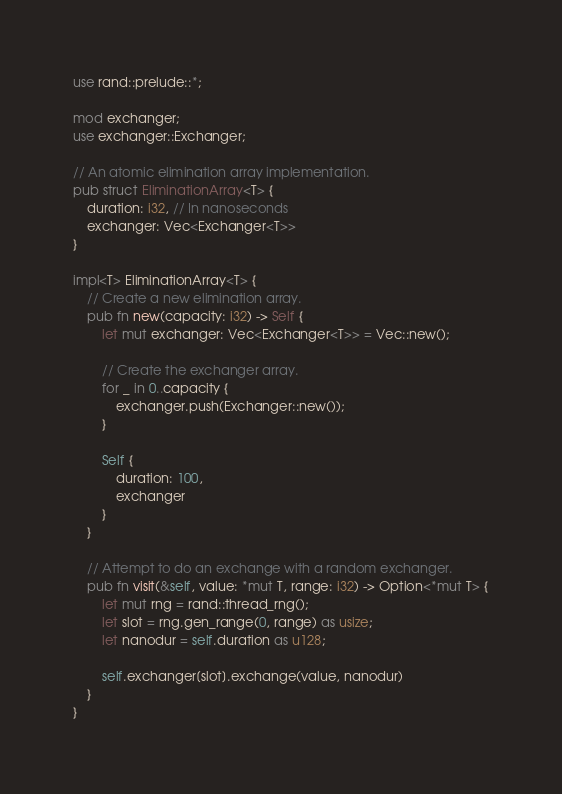<code> <loc_0><loc_0><loc_500><loc_500><_Rust_>use rand::prelude::*;

mod exchanger;
use exchanger::Exchanger;

// An atomic elimination array implementation.
pub struct EliminationArray<T> {
	duration: i32, // In nanoseconds
	exchanger: Vec<Exchanger<T>>
}

impl<T> EliminationArray<T> {
	// Create a new elimination array.
	pub fn new(capacity: i32) -> Self {
		let mut exchanger: Vec<Exchanger<T>> = Vec::new();

		// Create the exchanger array.
		for _ in 0..capacity {
			exchanger.push(Exchanger::new());
		}

		Self {
			duration: 100,
			exchanger
		}
	}

	// Attempt to do an exchange with a random exchanger.
	pub fn visit(&self, value: *mut T, range: i32) -> Option<*mut T> {
		let mut rng = rand::thread_rng();
		let slot = rng.gen_range(0, range) as usize;
		let nanodur = self.duration as u128;

		self.exchanger[slot].exchange(value, nanodur)
	}
}</code> 